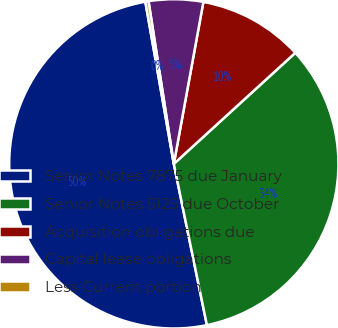Convert chart. <chart><loc_0><loc_0><loc_500><loc_500><pie_chart><fcel>Senior Notes 7875 due January<fcel>Senior Notes 5125 due October<fcel>Acquisition obligations due<fcel>Capital lease obligations<fcel>Less Current portion<nl><fcel>50.46%<fcel>33.57%<fcel>10.34%<fcel>5.33%<fcel>0.31%<nl></chart> 